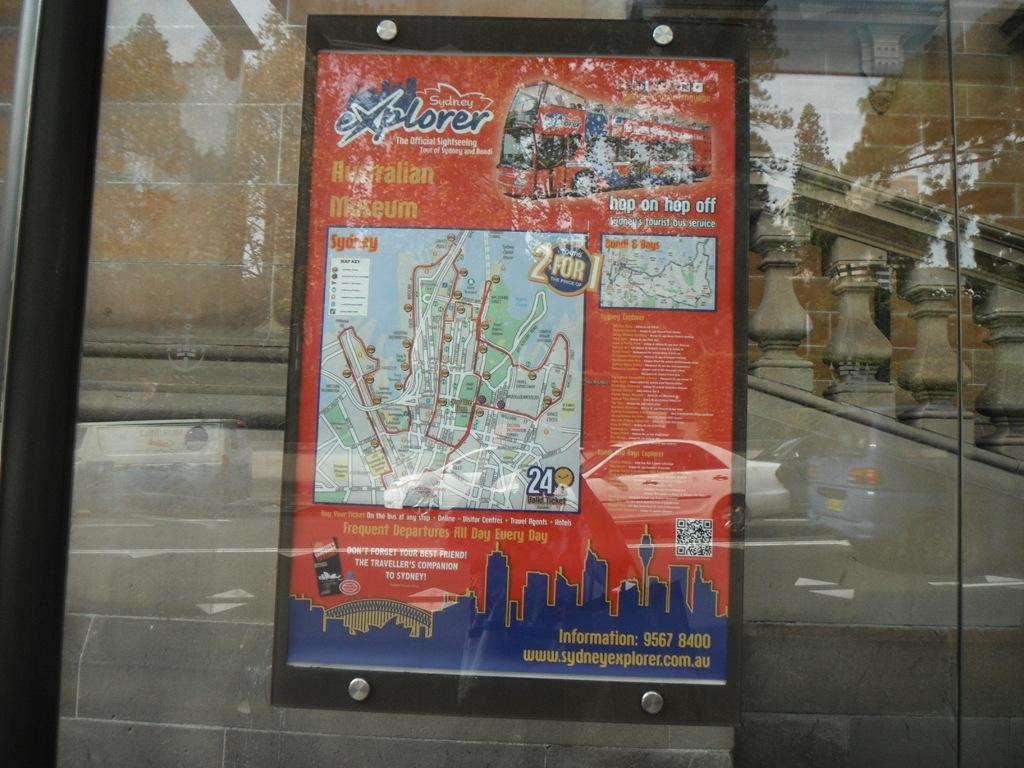Provide a one-sentence caption for the provided image. Sydney explorer poster for the Australian museum including a map. 